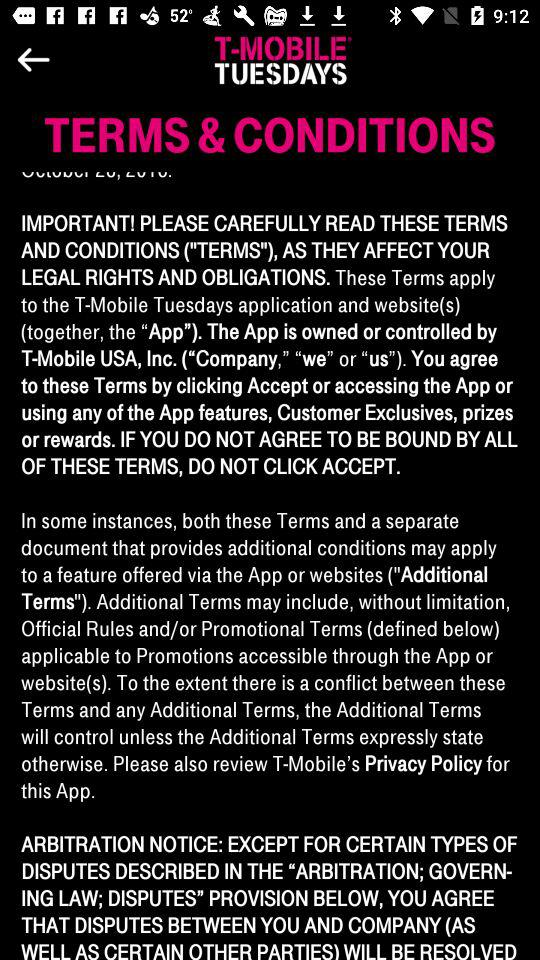How many more miles is option D than option A?
Answer the question using a single word or phrase. 4.3 